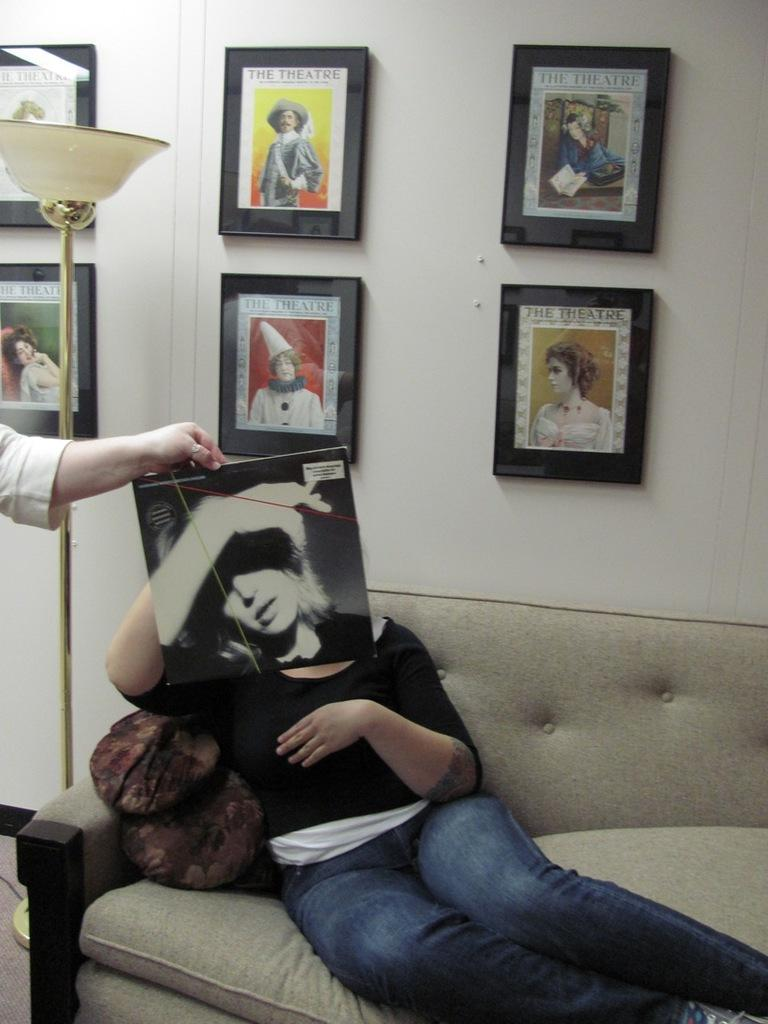What is the person sitting on in the room? There is a person sitting on a sofa in the room. How many people are in the room? There are two people in the room. What type of lighting is present in the room? There is a lamp in the room. What decorative elements can be seen on the walls in the room? There are frames on the wall in the room. What type of shop is visible in the room? There is no shop visible in the room; it is an indoor space with a sofa, another person, a lamp, and frames on the wall. 